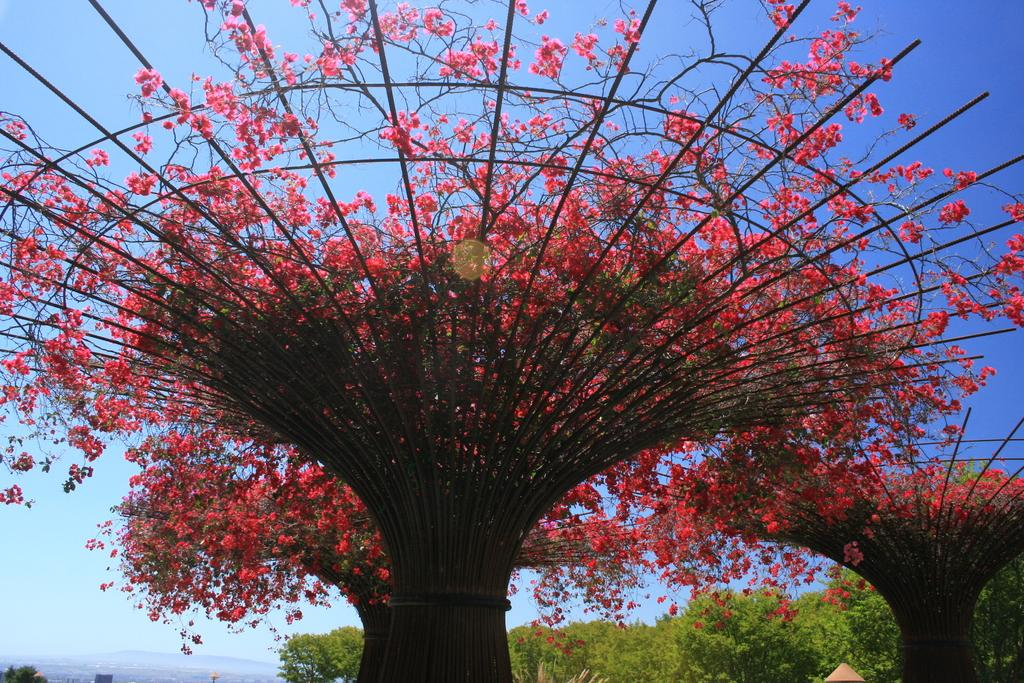Where was the picture taken? The picture was clicked outside. What can be seen in the center of the image? There are trees, metal rods, and flowers in the center of the image. What is visible in the background of the image? The sky is visible in the background of the image. What type of trees can be seen in the background? Green color trees are present in the background of the image. How many divisions are there in the stream in the image? There is no stream present in the image. What type of rake is being used to gather leaves in the image? There is no rake or leaves present in the image. 